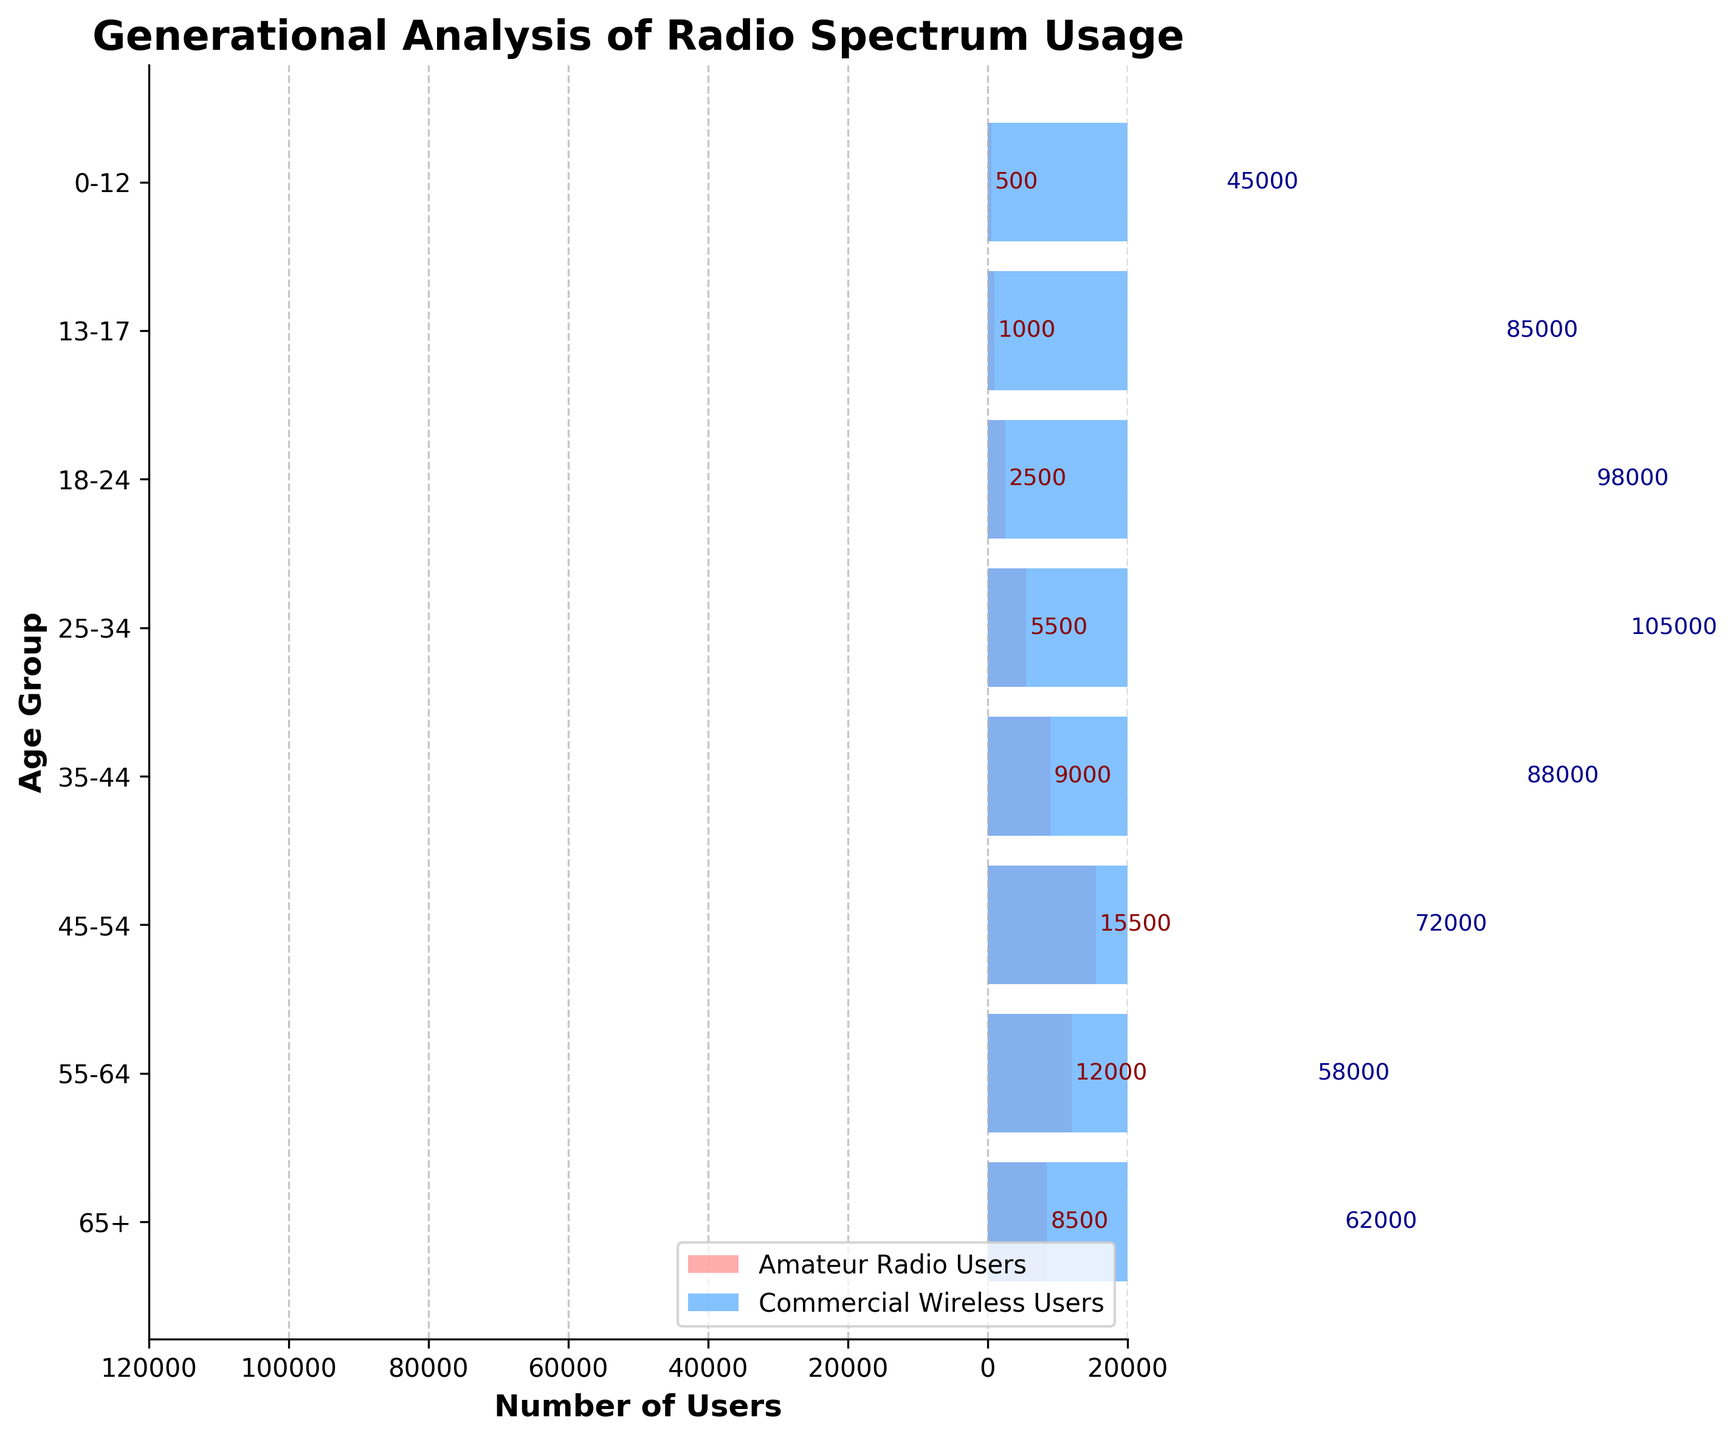What is the title of the figure? The title of the figure appears at the top of the plot and reads "Generational Analysis of Radio Spectrum Usage".
Answer: Generational Analysis of Radio Spectrum Usage What are the labels of the x-axis and y-axis? The x-axis label is "Number of Users" and the y-axis label is "Age Group". Both are written in bold.
Answer: Number of Users, Age Group Which age group has the highest number of Amateur Radio Users? To find the highest number of Amateur Radio Users, look for the tallest bar on the left side. The 45-54 age group has the tallest bar representing 15,500 users.
Answer: 45-54 What is the total number of Commercial Wireless Users in the 18-24 and 25-34 age groups combined? Add the absolute values of the Commercial Wireless Users for the 18-24 and 25-34 age groups, which are 98,000 and 105,000 respectively. 98,000 + 105,000 = 203,000.
Answer: 203,000 How many more Commercial Wireless Users are there than Amateur Radio Users in the 35-44 age group? Subtract the number of Amateur Radio Users (9,000) from the absolute value of Commercial Wireless Users (88,000) in the 35-44 age group. 88,000 - 9,000 = 79,000.
Answer: 79,000 Which age group has the smallest difference in the number of users between Amateur Radio and Commercial Wireless Services? Calculate the difference for each age group and find the smallest. For 0-12: 44,500 (45,000 - 500); for 13-17: 84,000 (85,000 - 1,000); for 18-24: 95,500 (98,000 - 2,500); for 25-34: 99,500 (105,000 - 5,500); for 35-44: 79,000 (88,000 - 9,000); for 45-54: 56,500 (72,000 - 15,500); for 55-64: 46,000 (58,000 - 12,000); for 65+: 53,500 (62,000 - 8,500). The smallest difference is 44,500 for the 0-12 age group.
Answer: 0-12 What's the average number of Amateur Radio Users across all age groups? Sum the Amateur Radio Users for all age groups and divide by the number of age groups. (8,500 + 12,000 + 15,500 + 9,000 + 5,500 + 2,500 + 1,000 + 500) / 8 = 54,500 / 8 ≈ 6,812.5.
Answer: 6,812.5 In which age group do Commercial Wireless Services have more users compared to Amateur Radio Users? Check age groups where the number of Commercial Wireless Users is greater than Amateur Radio Users. For all age groups, Commercial Wireless Services have more users, indicated by the values on the right being greater in magnitude than those on the left.
Answer: All age groups Which age group has the largest number of Commercial Wireless Users? Identify the age group with the longest bar on the right side. The 25-34 age group has the largest number of Commercial Wireless Users at 105,000.
Answer: 25-34 How does the population of 55-64 Amateur Radio Users compare to the 55-64 Commercial Wireless Users? The 55-64 Amateur Radio Users are 12,000 compared to 55-64 Commercial Wireless Users at 58,000. The Amateur Radio Users are far fewer.
Answer: Far fewer 